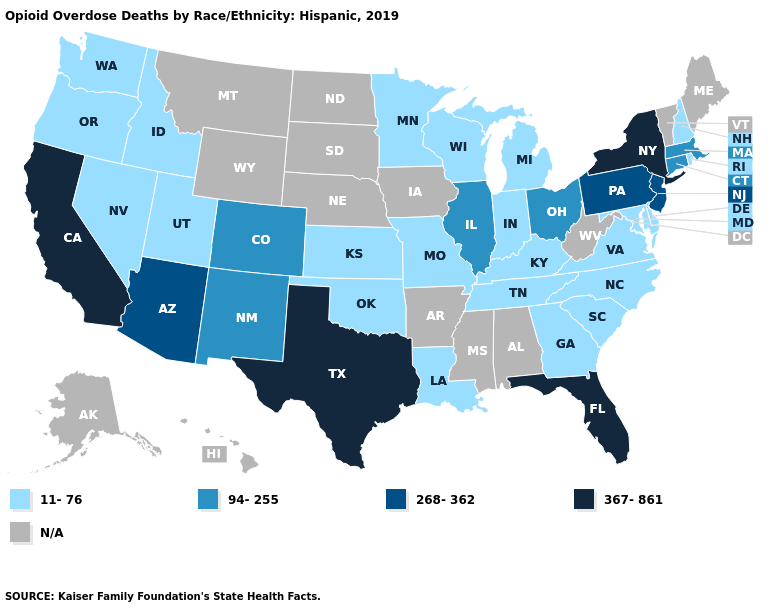Among the states that border Virginia , which have the lowest value?
Quick response, please. Kentucky, Maryland, North Carolina, Tennessee. What is the value of Idaho?
Concise answer only. 11-76. What is the value of Missouri?
Keep it brief. 11-76. What is the value of Rhode Island?
Quick response, please. 11-76. What is the highest value in the South ?
Quick response, please. 367-861. Which states have the lowest value in the West?
Concise answer only. Idaho, Nevada, Oregon, Utah, Washington. Does New Hampshire have the lowest value in the Northeast?
Write a very short answer. Yes. Does the first symbol in the legend represent the smallest category?
Answer briefly. Yes. What is the highest value in states that border Louisiana?
Short answer required. 367-861. Does the first symbol in the legend represent the smallest category?
Concise answer only. Yes. Which states have the highest value in the USA?
Answer briefly. California, Florida, New York, Texas. Among the states that border Delaware , does Maryland have the highest value?
Concise answer only. No. Which states have the lowest value in the MidWest?
Give a very brief answer. Indiana, Kansas, Michigan, Minnesota, Missouri, Wisconsin. Does Minnesota have the highest value in the USA?
Short answer required. No. 